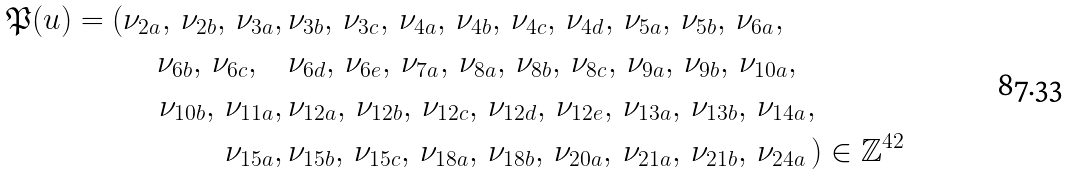<formula> <loc_0><loc_0><loc_500><loc_500>\mathfrak { P } ( u ) = ( \nu _ { 2 a } , \, \nu _ { 2 b } , \, \nu _ { 3 a } , \, & \nu _ { 3 b } , \, \nu _ { 3 c } , \, \nu _ { 4 a } , \, \nu _ { 4 b } , \, \nu _ { 4 c } , \, \nu _ { 4 d } , \, \nu _ { 5 a } , \, \nu _ { 5 b } , \, \nu _ { 6 a } , \\ \, \nu _ { 6 b } , \, \nu _ { 6 c } , \quad & \nu _ { 6 d } , \, \nu _ { 6 e } , \, \nu _ { 7 a } , \, \nu _ { 8 a } , \, \nu _ { 8 b } , \, \nu _ { 8 c } , \, \nu _ { 9 a } , \, \nu _ { 9 b } , \, \nu _ { 1 0 a } , \, \\ \nu _ { 1 0 b } , \, \nu _ { 1 1 a } , \, & \nu _ { 1 2 a } , \, \nu _ { 1 2 b } , \, \nu _ { 1 2 c } , \, \nu _ { 1 2 d } , \, \nu _ { 1 2 e } , \, \nu _ { 1 3 a } , \, \nu _ { 1 3 b } , \, \nu _ { 1 4 a } , \, \\ \nu _ { 1 5 a } , \, & \nu _ { 1 5 b } , \, \nu _ { 1 5 c } , \, \nu _ { 1 8 a } , \, \nu _ { 1 8 b } , \, \nu _ { 2 0 a } , \, \nu _ { 2 1 a } , \, \nu _ { 2 1 b } , \, \nu _ { 2 4 a } \, ) \in \mathbb { Z } ^ { 4 2 }</formula> 